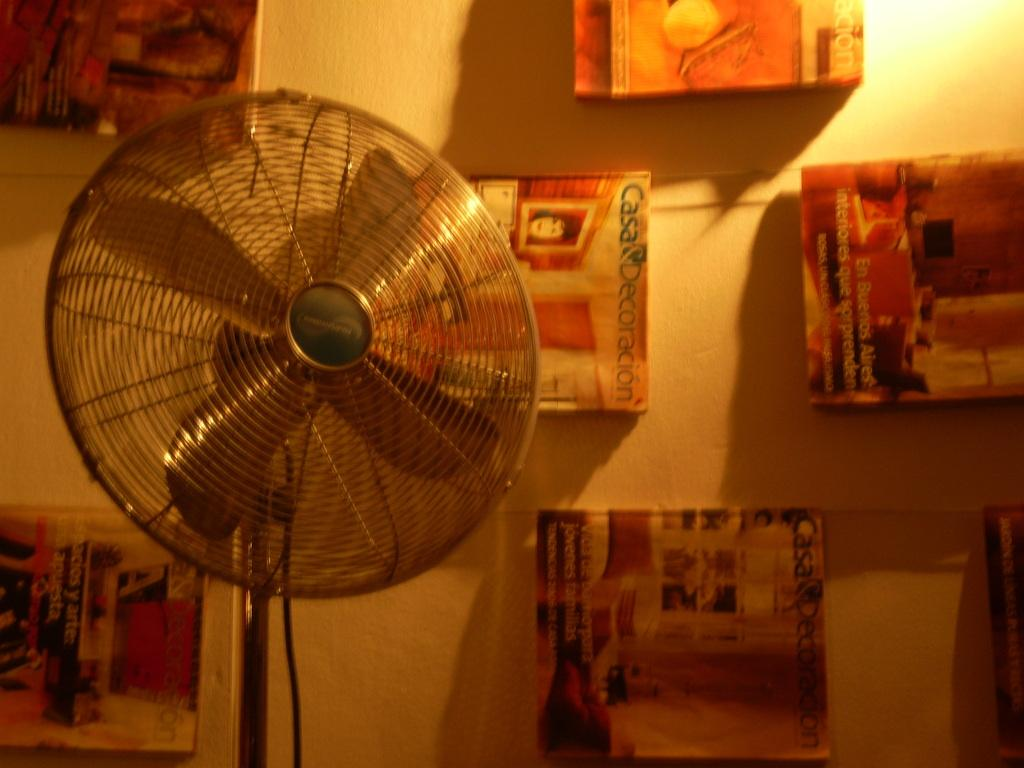<image>
Give a short and clear explanation of the subsequent image. a plaque on a wall that says 'casa decoracion' on it 